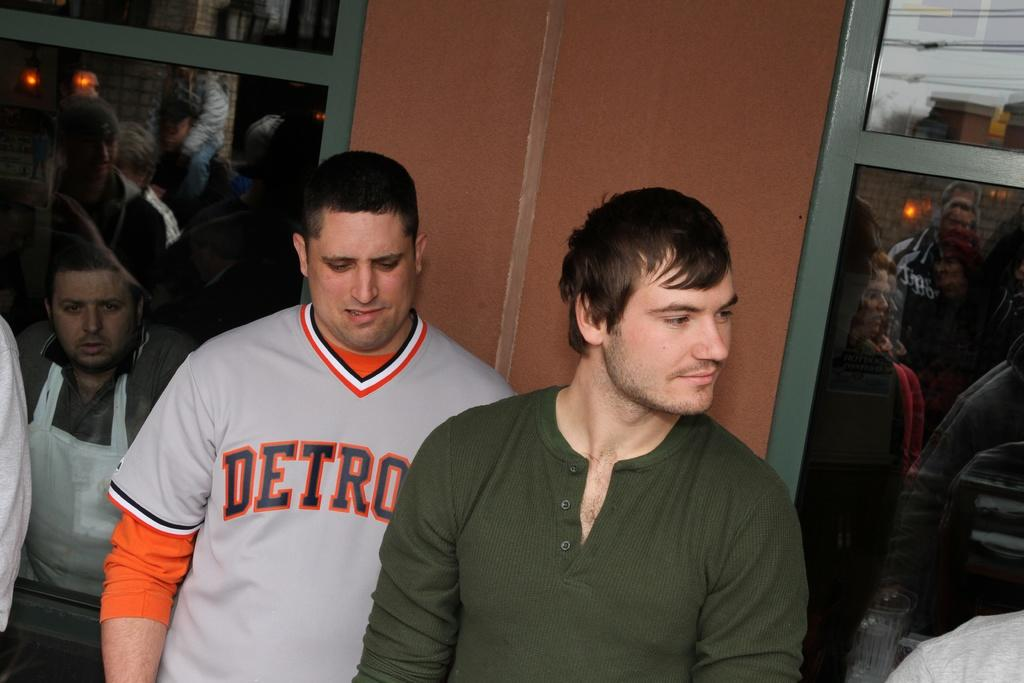<image>
Provide a brief description of the given image. A man in a Detroit shirt stands behind a man in a green shirt. 